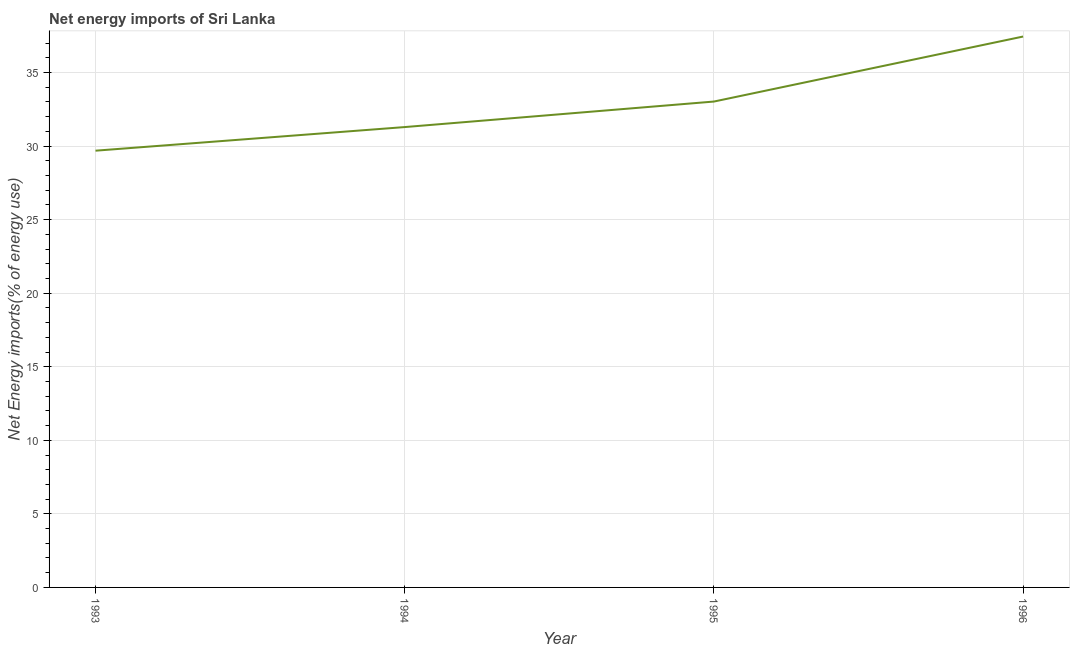What is the energy imports in 1995?
Offer a terse response. 33.02. Across all years, what is the maximum energy imports?
Make the answer very short. 37.44. Across all years, what is the minimum energy imports?
Give a very brief answer. 29.68. What is the sum of the energy imports?
Provide a short and direct response. 131.44. What is the difference between the energy imports in 1994 and 1995?
Offer a very short reply. -1.73. What is the average energy imports per year?
Ensure brevity in your answer.  32.86. What is the median energy imports?
Offer a terse response. 32.16. What is the ratio of the energy imports in 1994 to that in 1996?
Your response must be concise. 0.84. What is the difference between the highest and the second highest energy imports?
Offer a very short reply. 4.42. What is the difference between the highest and the lowest energy imports?
Provide a short and direct response. 7.76. Does the energy imports monotonically increase over the years?
Offer a terse response. Yes. What is the difference between two consecutive major ticks on the Y-axis?
Make the answer very short. 5. What is the title of the graph?
Ensure brevity in your answer.  Net energy imports of Sri Lanka. What is the label or title of the Y-axis?
Ensure brevity in your answer.  Net Energy imports(% of energy use). What is the Net Energy imports(% of energy use) of 1993?
Your answer should be compact. 29.68. What is the Net Energy imports(% of energy use) in 1994?
Give a very brief answer. 31.29. What is the Net Energy imports(% of energy use) of 1995?
Ensure brevity in your answer.  33.02. What is the Net Energy imports(% of energy use) in 1996?
Provide a short and direct response. 37.44. What is the difference between the Net Energy imports(% of energy use) in 1993 and 1994?
Your response must be concise. -1.6. What is the difference between the Net Energy imports(% of energy use) in 1993 and 1995?
Your answer should be compact. -3.34. What is the difference between the Net Energy imports(% of energy use) in 1993 and 1996?
Make the answer very short. -7.76. What is the difference between the Net Energy imports(% of energy use) in 1994 and 1995?
Make the answer very short. -1.73. What is the difference between the Net Energy imports(% of energy use) in 1994 and 1996?
Make the answer very short. -6.15. What is the difference between the Net Energy imports(% of energy use) in 1995 and 1996?
Offer a very short reply. -4.42. What is the ratio of the Net Energy imports(% of energy use) in 1993 to that in 1994?
Ensure brevity in your answer.  0.95. What is the ratio of the Net Energy imports(% of energy use) in 1993 to that in 1995?
Provide a short and direct response. 0.9. What is the ratio of the Net Energy imports(% of energy use) in 1993 to that in 1996?
Your answer should be very brief. 0.79. What is the ratio of the Net Energy imports(% of energy use) in 1994 to that in 1995?
Provide a short and direct response. 0.95. What is the ratio of the Net Energy imports(% of energy use) in 1994 to that in 1996?
Offer a very short reply. 0.84. What is the ratio of the Net Energy imports(% of energy use) in 1995 to that in 1996?
Your response must be concise. 0.88. 